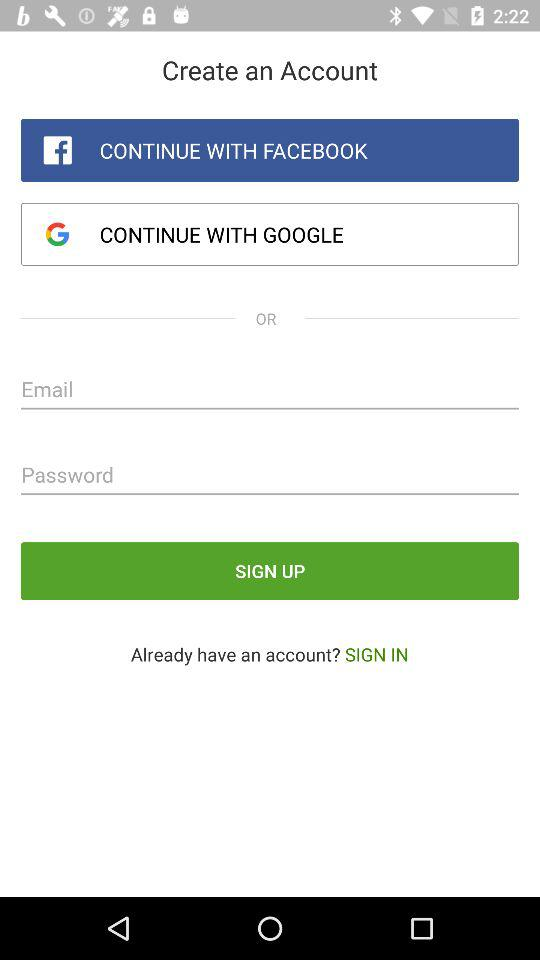How many social media login options are there?
Answer the question using a single word or phrase. 2 